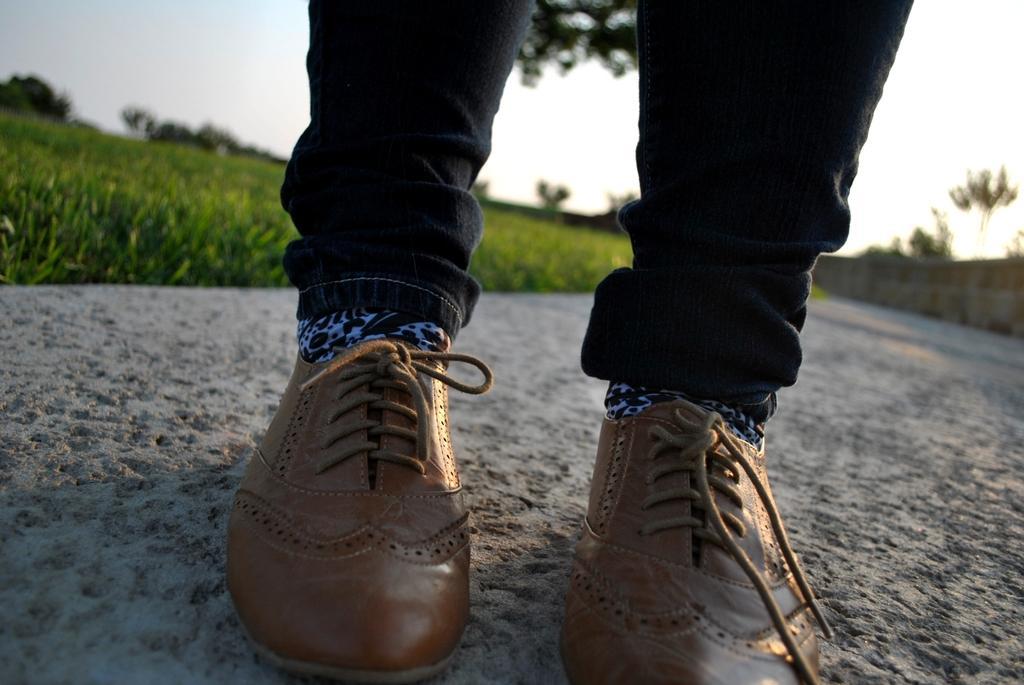Can you describe this image briefly? In this image I can see a person's legs wearing shoes and this person is standing on the ground. On the left side, I can see the grass. On the right side there is a wall. In the background there are many trees. At the top of the image I can see the sky. 